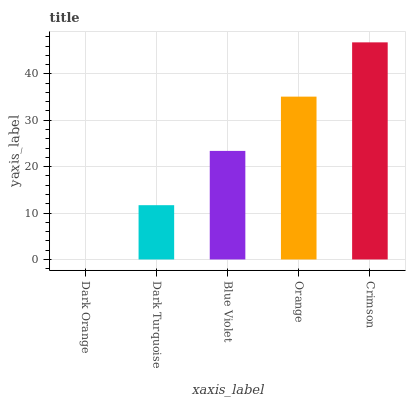Is Dark Orange the minimum?
Answer yes or no. Yes. Is Crimson the maximum?
Answer yes or no. Yes. Is Dark Turquoise the minimum?
Answer yes or no. No. Is Dark Turquoise the maximum?
Answer yes or no. No. Is Dark Turquoise greater than Dark Orange?
Answer yes or no. Yes. Is Dark Orange less than Dark Turquoise?
Answer yes or no. Yes. Is Dark Orange greater than Dark Turquoise?
Answer yes or no. No. Is Dark Turquoise less than Dark Orange?
Answer yes or no. No. Is Blue Violet the high median?
Answer yes or no. Yes. Is Blue Violet the low median?
Answer yes or no. Yes. Is Orange the high median?
Answer yes or no. No. Is Orange the low median?
Answer yes or no. No. 